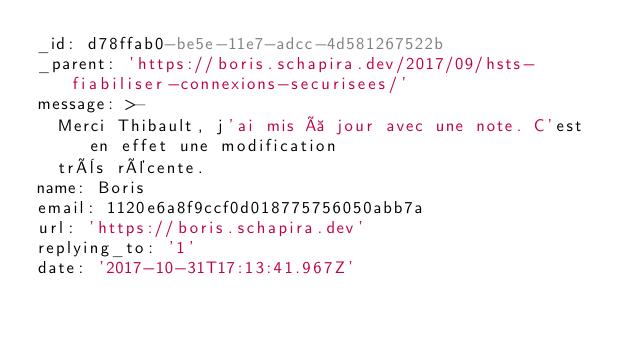Convert code to text. <code><loc_0><loc_0><loc_500><loc_500><_YAML_>_id: d78ffab0-be5e-11e7-adcc-4d581267522b
_parent: 'https://boris.schapira.dev/2017/09/hsts-fiabiliser-connexions-securisees/'
message: >-
  Merci Thibault, j'ai mis à jour avec une note. C'est en effet une modification
  très récente.
name: Boris
email: 1120e6a8f9ccf0d018775756050abb7a
url: 'https://boris.schapira.dev'
replying_to: '1'
date: '2017-10-31T17:13:41.967Z'
</code> 